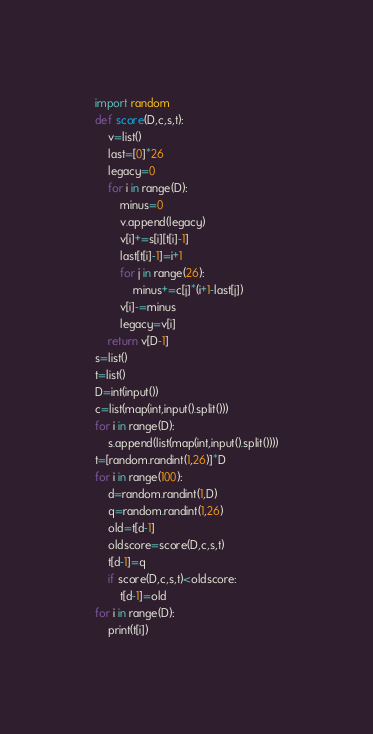Convert code to text. <code><loc_0><loc_0><loc_500><loc_500><_Python_>import random
def score(D,c,s,t):
    v=list()
    last=[0]*26
    legacy=0
    for i in range(D):
        minus=0
        v.append(legacy)
        v[i]+=s[i][t[i]-1]
        last[t[i]-1]=i+1
        for j in range(26):
            minus+=c[j]*(i+1-last[j])
        v[i]-=minus
        legacy=v[i]
    return v[D-1]
s=list()
t=list()
D=int(input())
c=list(map(int,input().split()))
for i in range(D):
    s.append(list(map(int,input().split())))
t=[random.randint(1,26)]*D
for i in range(100):
    d=random.randint(1,D)
    q=random.randint(1,26)
    old=t[d-1]
    oldscore=score(D,c,s,t)
    t[d-1]=q
    if score(D,c,s,t)<oldscore:
        t[d-1]=old
for i in range(D):
    print(t[i])</code> 